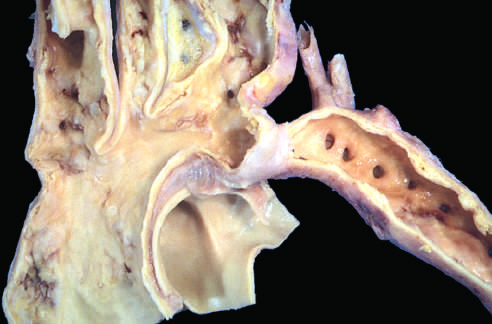what are the lower extremities perfused by?
Answer the question using a single word or phrase. By way of dilated 